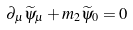Convert formula to latex. <formula><loc_0><loc_0><loc_500><loc_500>\partial _ { \mu } \widetilde { \psi } _ { \mu } + m _ { 2 } \widetilde { \psi } _ { 0 } = 0</formula> 